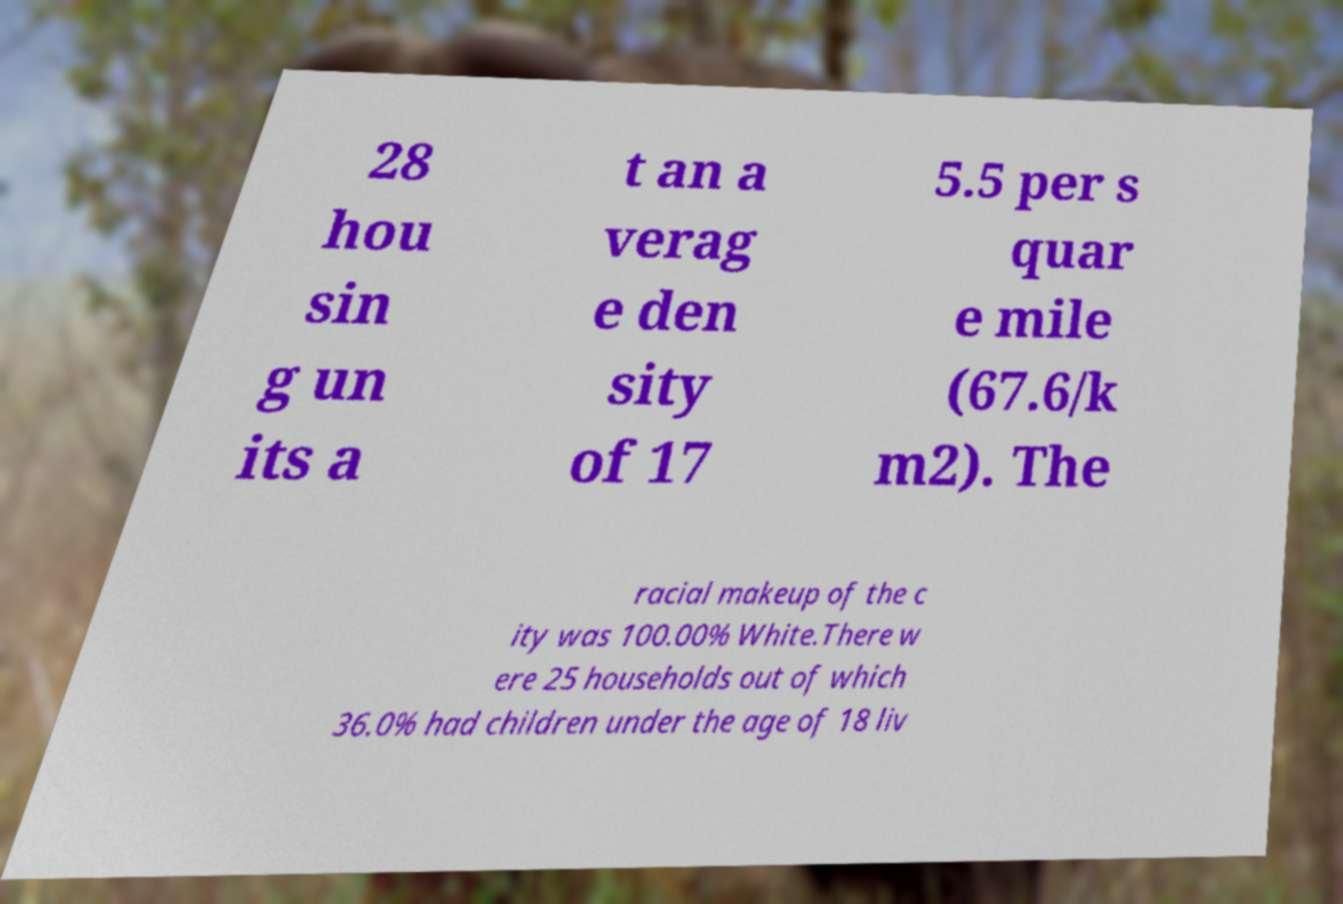What messages or text are displayed in this image? I need them in a readable, typed format. 28 hou sin g un its a t an a verag e den sity of 17 5.5 per s quar e mile (67.6/k m2). The racial makeup of the c ity was 100.00% White.There w ere 25 households out of which 36.0% had children under the age of 18 liv 